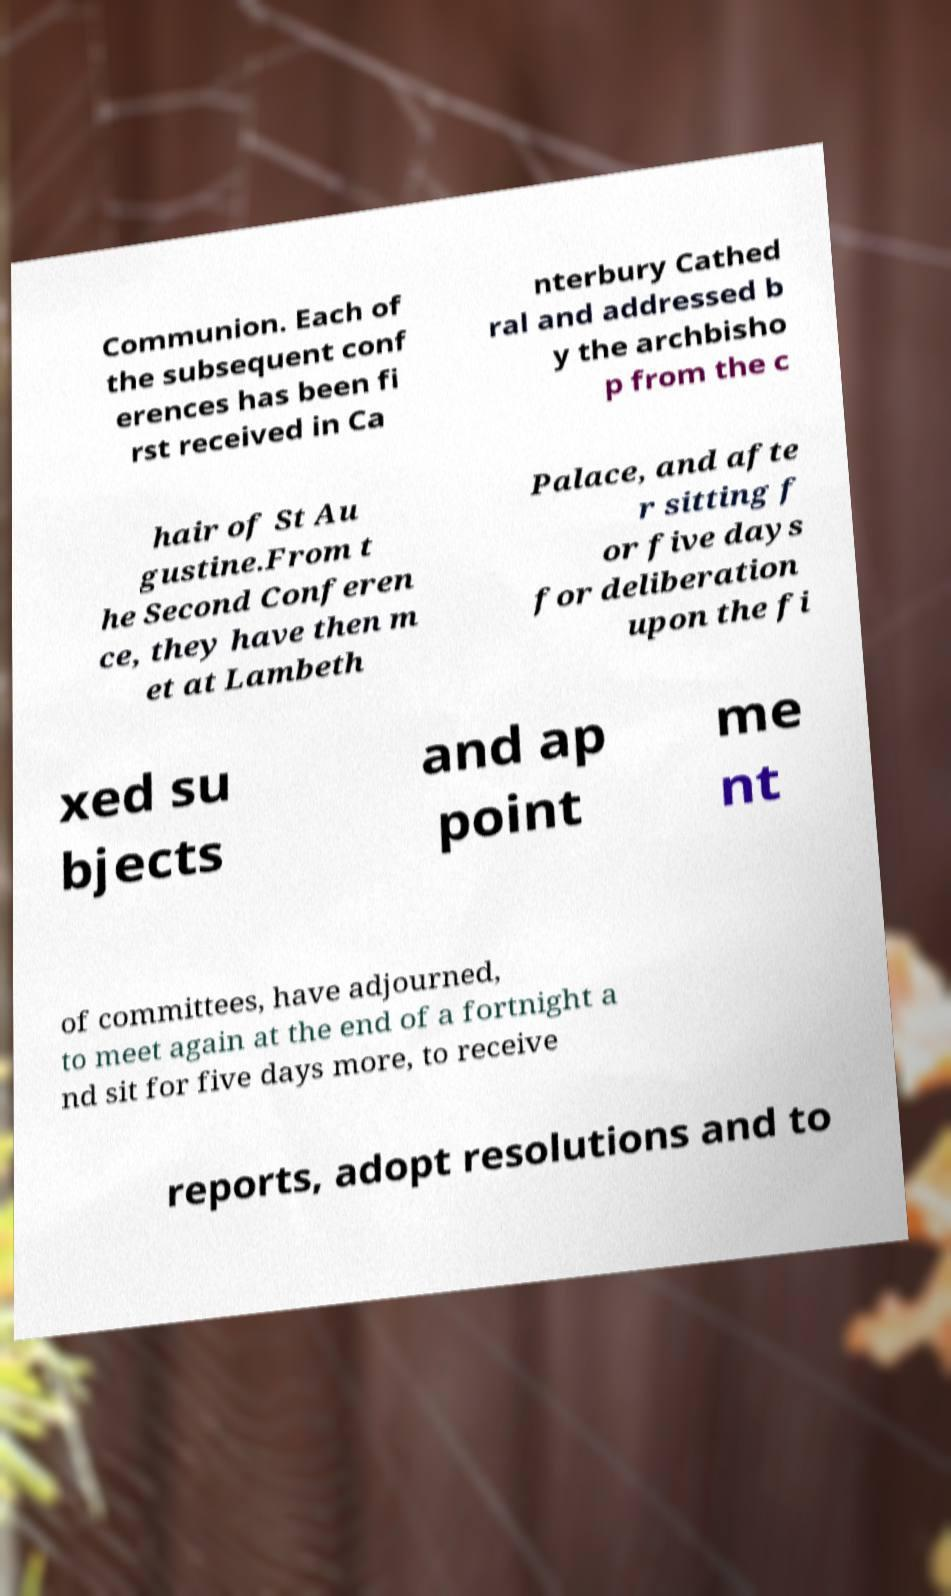Can you read and provide the text displayed in the image?This photo seems to have some interesting text. Can you extract and type it out for me? Communion. Each of the subsequent conf erences has been fi rst received in Ca nterbury Cathed ral and addressed b y the archbisho p from the c hair of St Au gustine.From t he Second Conferen ce, they have then m et at Lambeth Palace, and afte r sitting f or five days for deliberation upon the fi xed su bjects and ap point me nt of committees, have adjourned, to meet again at the end of a fortnight a nd sit for five days more, to receive reports, adopt resolutions and to 